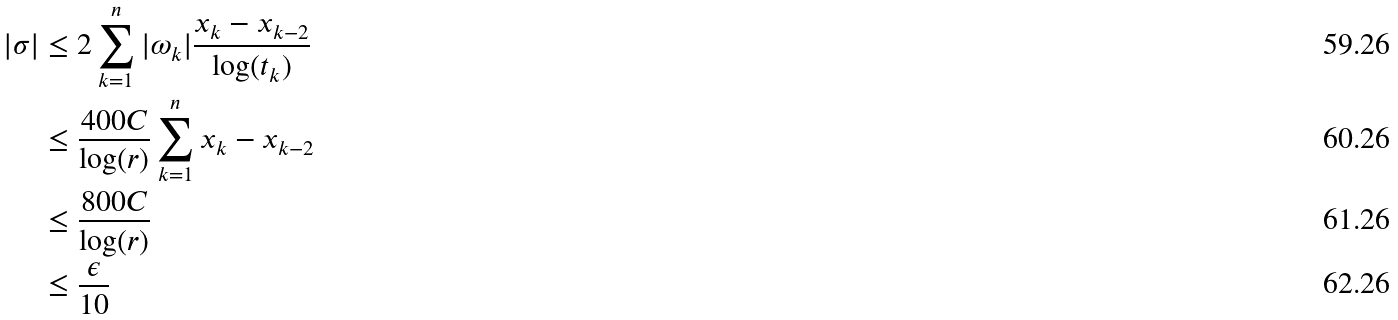Convert formula to latex. <formula><loc_0><loc_0><loc_500><loc_500>| \sigma | & \leq 2 \sum _ { k = 1 } ^ { n } | \omega _ { k } | \frac { x _ { k } - x _ { k - 2 } } { \log ( t _ { k } ) } \\ & \leq \frac { 4 0 0 C } { \log ( r ) } \sum _ { k = 1 } ^ { n } { x _ { k } - x _ { k - 2 } } \\ & \leq \frac { 8 0 0 C } { \log ( r ) } \\ & \leq \frac { \epsilon } { 1 0 }</formula> 